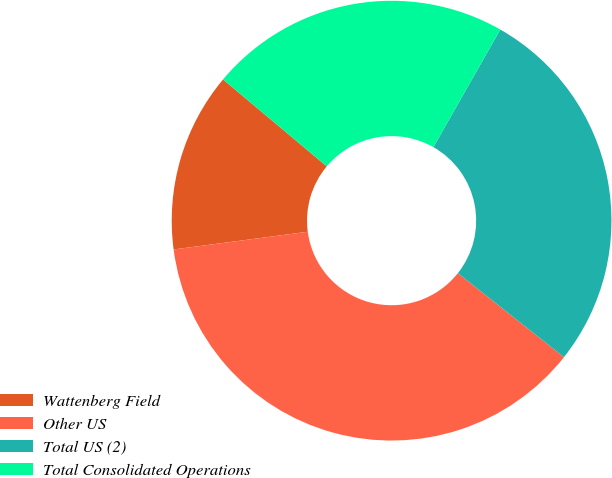Convert chart to OTSL. <chart><loc_0><loc_0><loc_500><loc_500><pie_chart><fcel>Wattenberg Field<fcel>Other US<fcel>Total US (2)<fcel>Total Consolidated Operations<nl><fcel>13.19%<fcel>37.25%<fcel>27.43%<fcel>22.13%<nl></chart> 